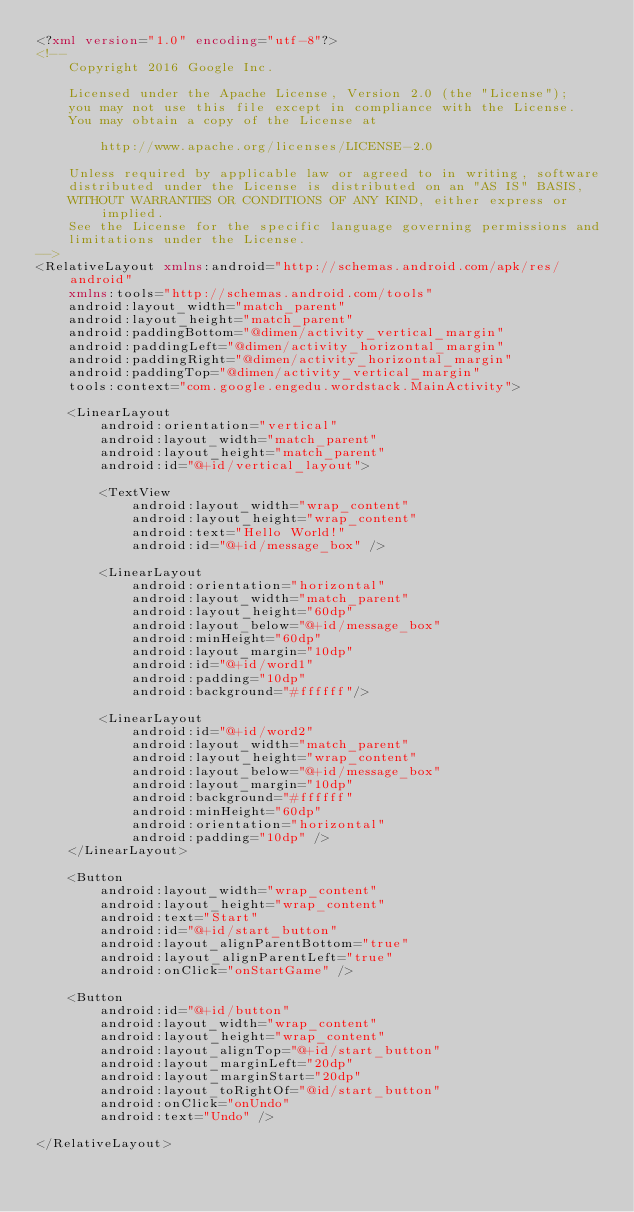<code> <loc_0><loc_0><loc_500><loc_500><_XML_><?xml version="1.0" encoding="utf-8"?>
<!--
    Copyright 2016 Google Inc.

    Licensed under the Apache License, Version 2.0 (the "License");
    you may not use this file except in compliance with the License.
    You may obtain a copy of the License at

        http://www.apache.org/licenses/LICENSE-2.0

    Unless required by applicable law or agreed to in writing, software
    distributed under the License is distributed on an "AS IS" BASIS,
    WITHOUT WARRANTIES OR CONDITIONS OF ANY KIND, either express or implied.
    See the License for the specific language governing permissions and
    limitations under the License.
-->
<RelativeLayout xmlns:android="http://schemas.android.com/apk/res/android"
    xmlns:tools="http://schemas.android.com/tools"
    android:layout_width="match_parent"
    android:layout_height="match_parent"
    android:paddingBottom="@dimen/activity_vertical_margin"
    android:paddingLeft="@dimen/activity_horizontal_margin"
    android:paddingRight="@dimen/activity_horizontal_margin"
    android:paddingTop="@dimen/activity_vertical_margin"
    tools:context="com.google.engedu.wordstack.MainActivity">

    <LinearLayout
        android:orientation="vertical"
        android:layout_width="match_parent"
        android:layout_height="match_parent"
        android:id="@+id/vertical_layout">

        <TextView
            android:layout_width="wrap_content"
            android:layout_height="wrap_content"
            android:text="Hello World!"
            android:id="@+id/message_box" />

        <LinearLayout
            android:orientation="horizontal"
            android:layout_width="match_parent"
            android:layout_height="60dp"
            android:layout_below="@+id/message_box"
            android:minHeight="60dp"
            android:layout_margin="10dp"
            android:id="@+id/word1"
            android:padding="10dp"
            android:background="#ffffff"/>

        <LinearLayout
            android:id="@+id/word2"
            android:layout_width="match_parent"
            android:layout_height="wrap_content"
            android:layout_below="@+id/message_box"
            android:layout_margin="10dp"
            android:background="#ffffff"
            android:minHeight="60dp"
            android:orientation="horizontal"
            android:padding="10dp" />
    </LinearLayout>

    <Button
        android:layout_width="wrap_content"
        android:layout_height="wrap_content"
        android:text="Start"
        android:id="@+id/start_button"
        android:layout_alignParentBottom="true"
        android:layout_alignParentLeft="true"
        android:onClick="onStartGame" />

    <Button
        android:id="@+id/button"
        android:layout_width="wrap_content"
        android:layout_height="wrap_content"
        android:layout_alignTop="@+id/start_button"
        android:layout_marginLeft="20dp"
        android:layout_marginStart="20dp"
        android:layout_toRightOf="@id/start_button"
        android:onClick="onUndo"
        android:text="Undo" />

</RelativeLayout></code> 